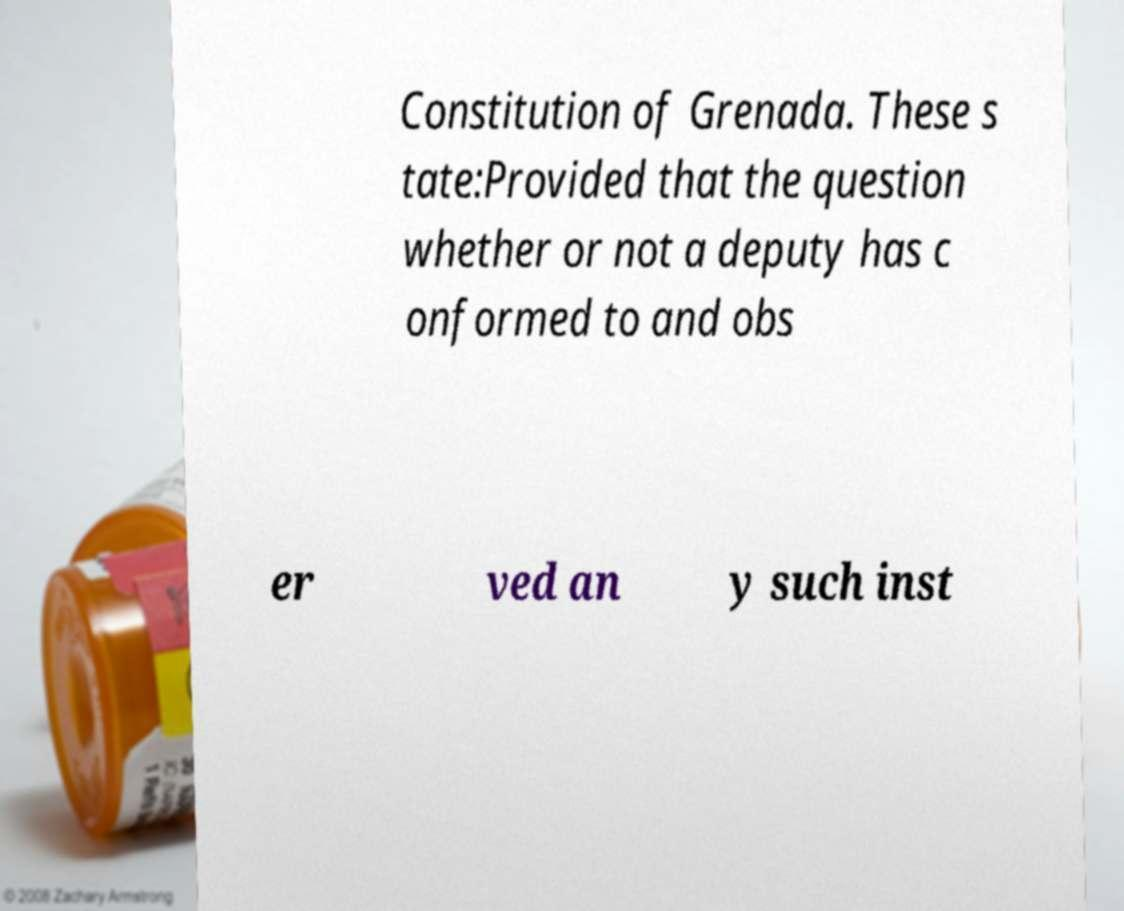For documentation purposes, I need the text within this image transcribed. Could you provide that? Constitution of Grenada. These s tate:Provided that the question whether or not a deputy has c onformed to and obs er ved an y such inst 